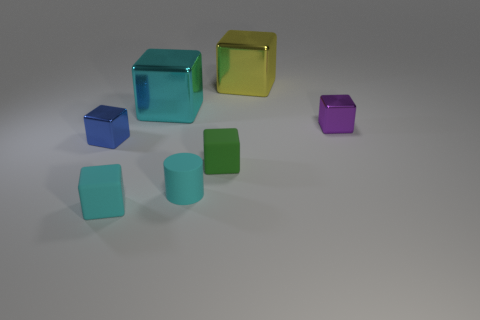Can you tell me what the transparent objects in the image are made of? The transparent objects in the image appear to be made of glass or a clear plastic due to the way they reflect and refract light, much like how real glass or transparent acrylic objects would do in a similar setting. 